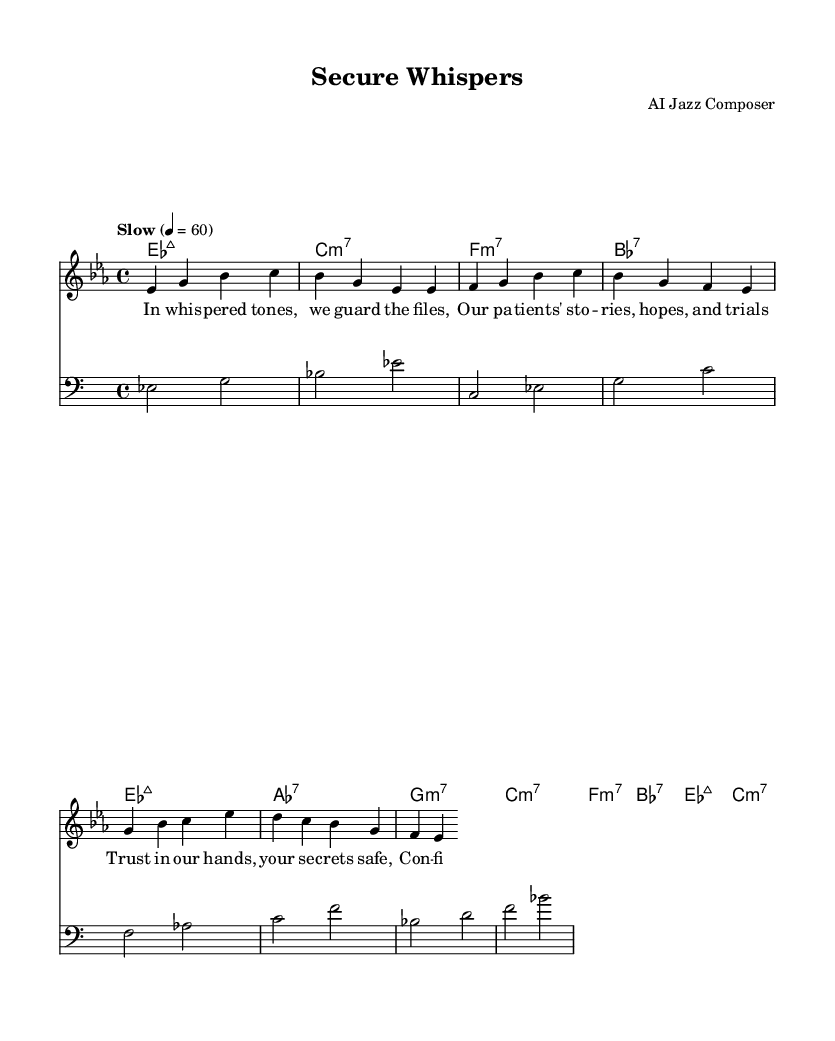What is the key signature of this music? The key signature shows two flats, indicating it is in the key of E flat major, which is typical in jazz compositions.
Answer: E flat major What is the time signature of this piece? The time signature is indicated as 4/4, which means there are four beats in a measure and a quarter note gets one beat. This is a common time signature in jazz.
Answer: 4/4 What is the tempo marking of the piece? The tempo marking states "Slow" with a metronome marking of 60 beats per minute, indicating the piece should be played at a leisurely pace, typical for mellow jazz.
Answer: Slow How many measures are in the verse? Counting the measures from the provided melody section, the verse contains a total of 8 measures, which is a common structure in jazz vocal pieces for balanced phrasing.
Answer: 8 What type of chords are used in the harmonies? The chords listed in the harmonies include major sevenths, minor sevenths, and dominant sevenths, which are characteristic of jazz music, allowing for rich harmonic color.
Answer: Major sevenths, minor sevenths, dominant sevenths What is the primary theme expressed in the lyrics? The lyrics express themes of trust and confidentiality, emphasizing the secure handling of patient information, aligning well with the mellow and introspective nature of jazz vocals.
Answer: Trust and confidentiality What characterizes the style of the vocals in this piece? The style of the vocals is characterized by smooth, soft delivery, as indicated by the use of phrases such as "whispered tones" and "guard the files," typical of mellow jazz vocal style to convey emotion.
Answer: Smooth and soft delivery 